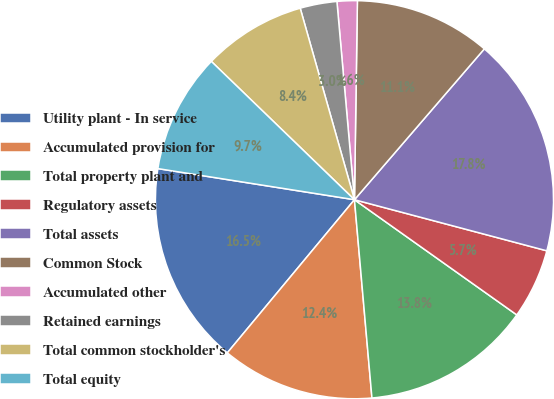<chart> <loc_0><loc_0><loc_500><loc_500><pie_chart><fcel>Utility plant - In service<fcel>Accumulated provision for<fcel>Total property plant and<fcel>Regulatory assets<fcel>Total assets<fcel>Common Stock<fcel>Accumulated other<fcel>Retained earnings<fcel>Total common stockholder's<fcel>Total equity<nl><fcel>16.47%<fcel>12.43%<fcel>13.78%<fcel>5.69%<fcel>17.82%<fcel>11.08%<fcel>1.64%<fcel>2.99%<fcel>8.38%<fcel>9.73%<nl></chart> 